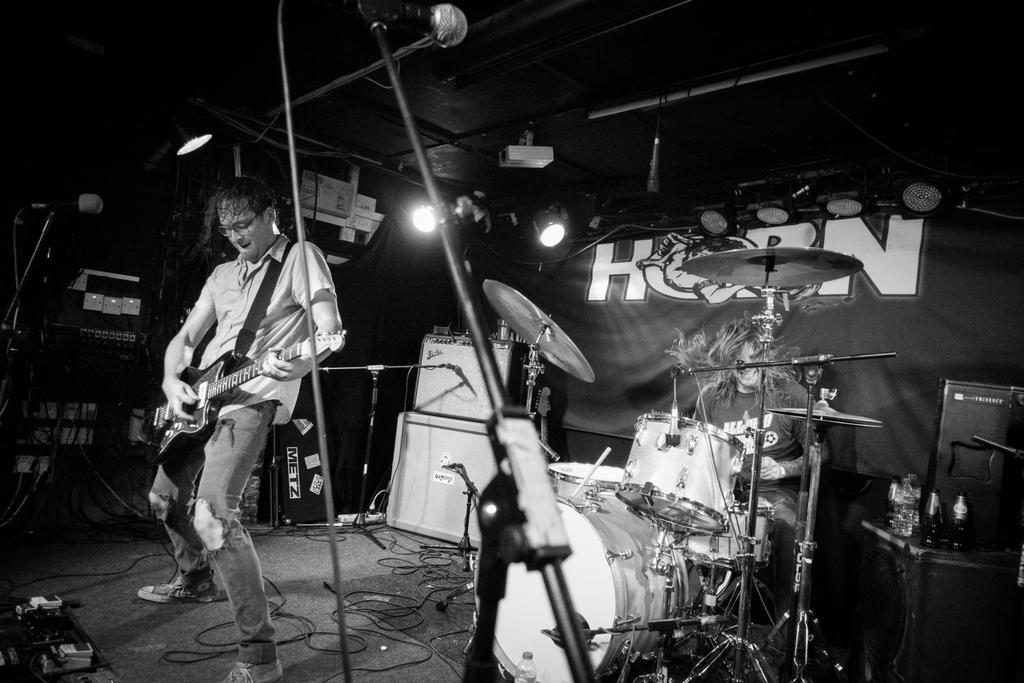What is the man in the image holding? The man is holding a guitar. What is the other man in the image doing? The other man is playing the drum set. What type of musical instruments are present in the image? There is a guitar and a drum set in the image. What is the color scheme of the image? The image is in black and white color. Can you see a chicken in the image? No, there is no chicken present in the image. Is there a battle taking place in the image? No, there is no battle depicted in the image; it features two men playing musical instruments. 